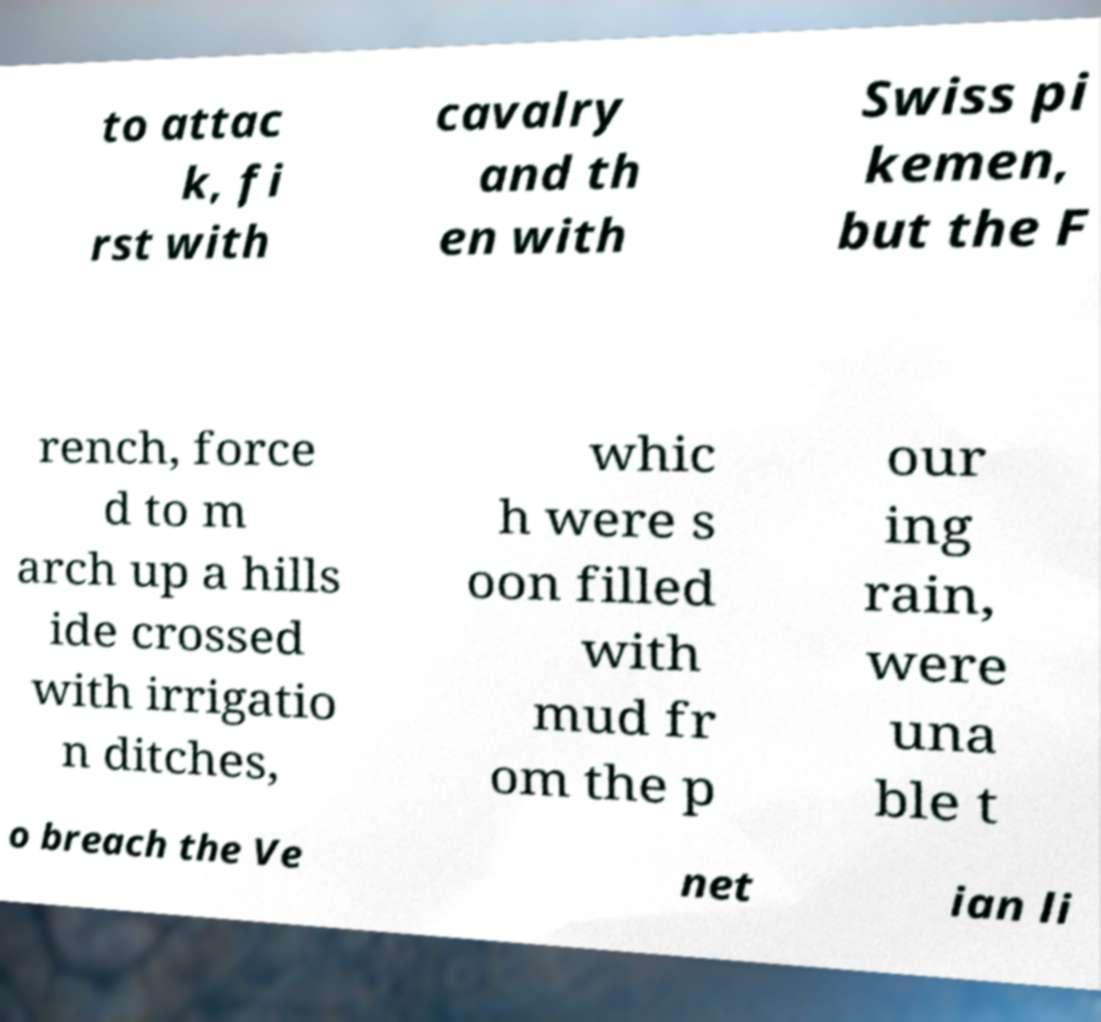Please identify and transcribe the text found in this image. to attac k, fi rst with cavalry and th en with Swiss pi kemen, but the F rench, force d to m arch up a hills ide crossed with irrigatio n ditches, whic h were s oon filled with mud fr om the p our ing rain, were una ble t o breach the Ve net ian li 